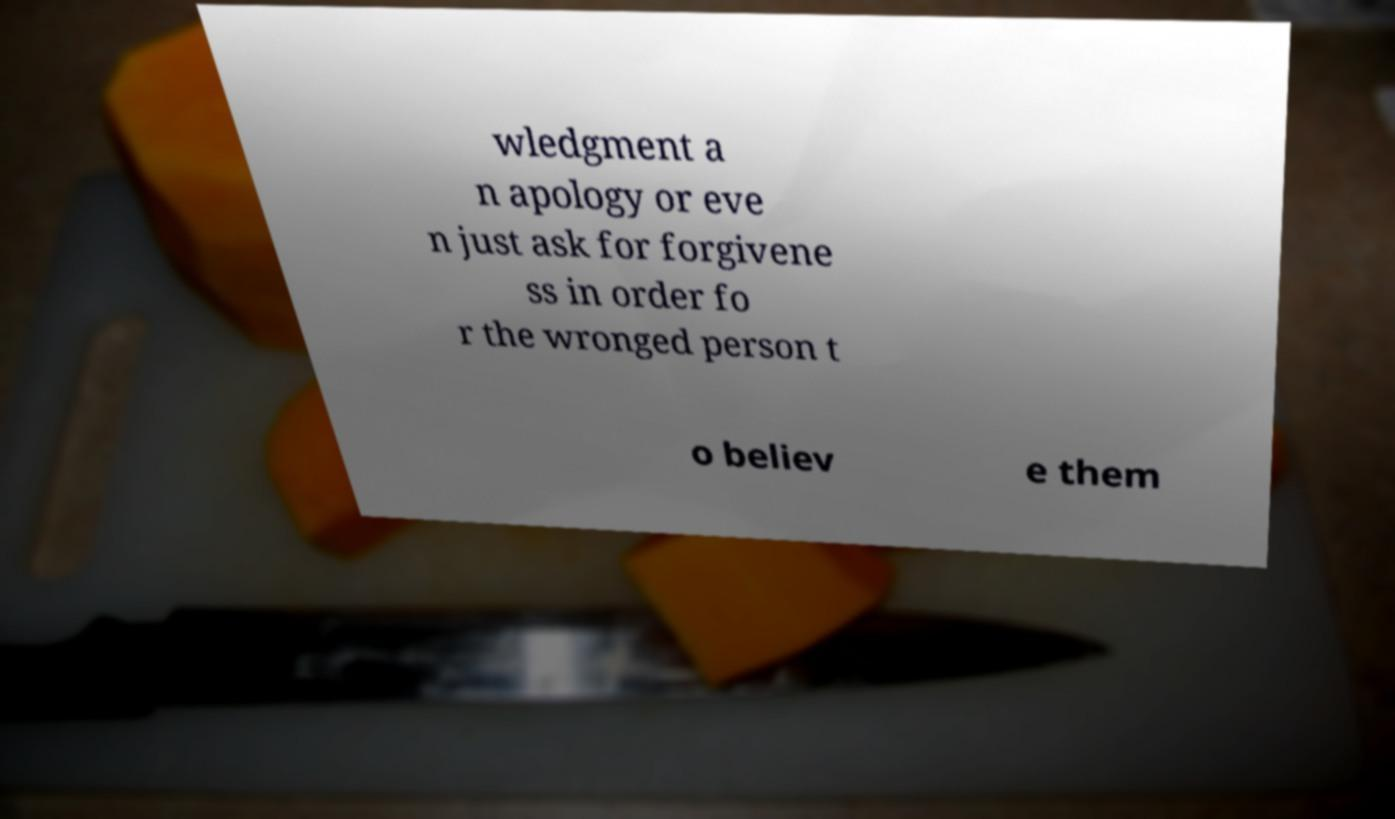Can you accurately transcribe the text from the provided image for me? wledgment a n apology or eve n just ask for forgivene ss in order fo r the wronged person t o believ e them 